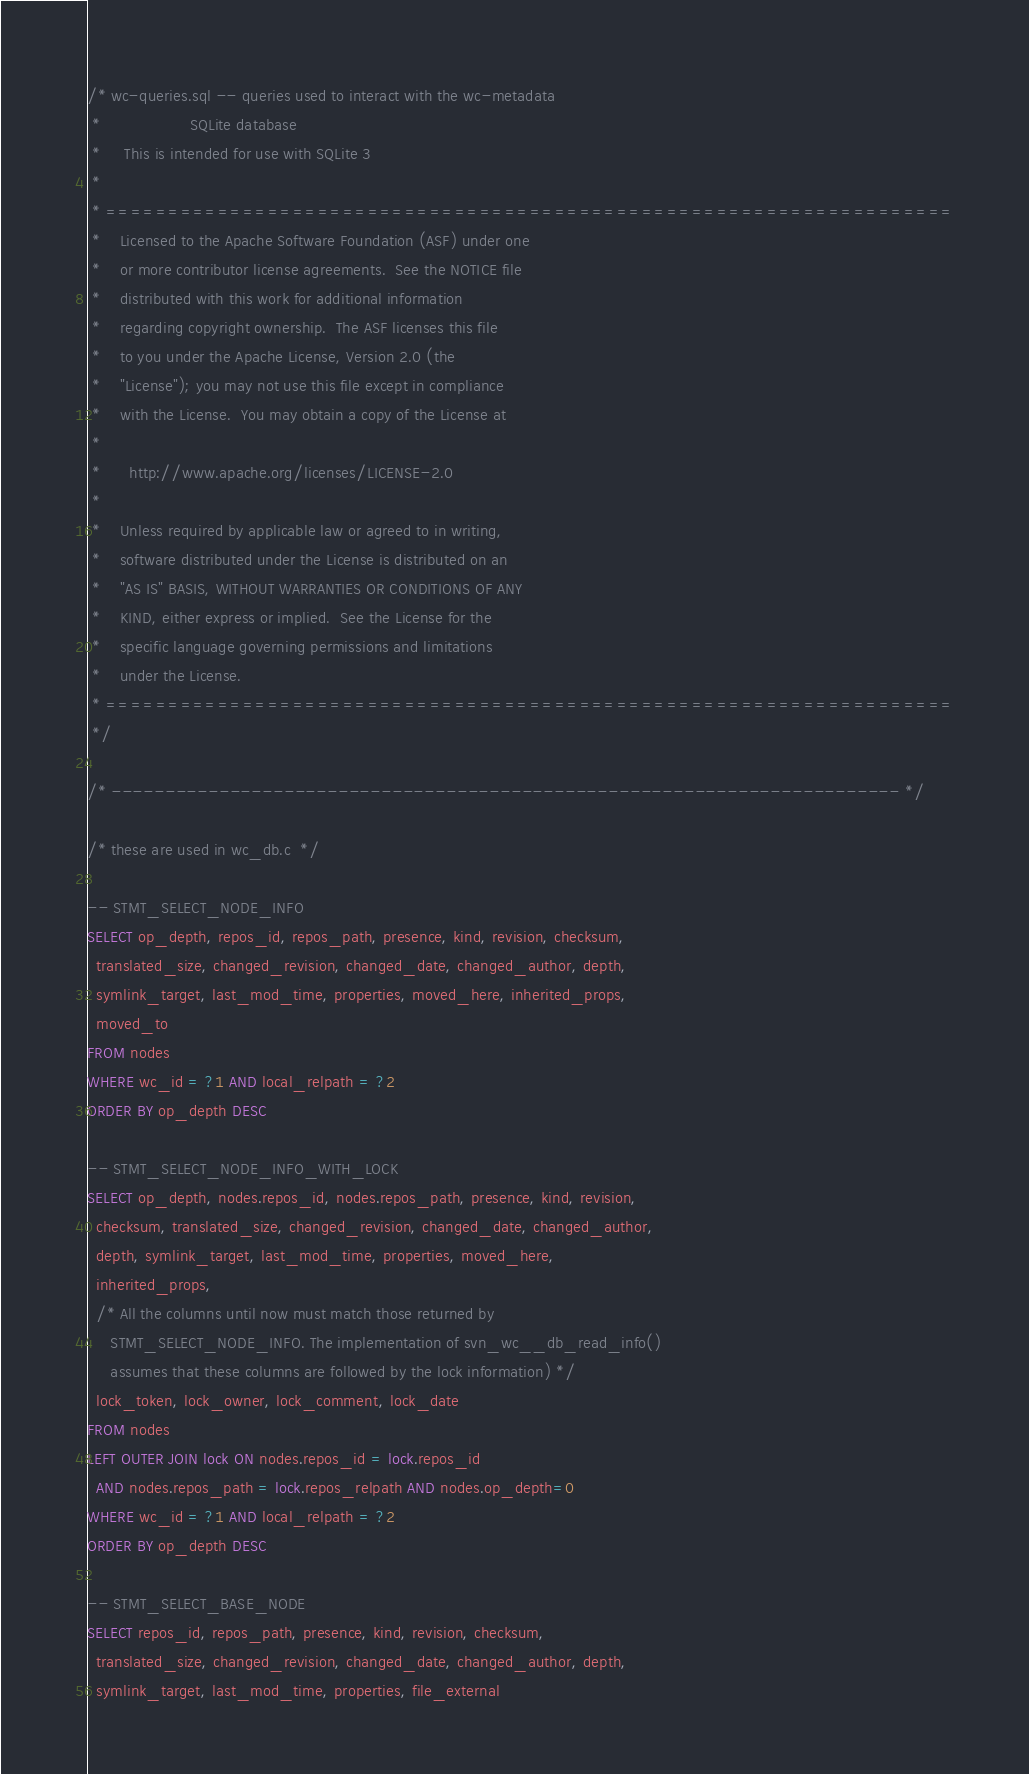<code> <loc_0><loc_0><loc_500><loc_500><_SQL_>/* wc-queries.sql -- queries used to interact with the wc-metadata
 *                   SQLite database
 *     This is intended for use with SQLite 3
 *
 * ====================================================================
 *    Licensed to the Apache Software Foundation (ASF) under one
 *    or more contributor license agreements.  See the NOTICE file
 *    distributed with this work for additional information
 *    regarding copyright ownership.  The ASF licenses this file
 *    to you under the Apache License, Version 2.0 (the
 *    "License"); you may not use this file except in compliance
 *    with the License.  You may obtain a copy of the License at
 *
 *      http://www.apache.org/licenses/LICENSE-2.0
 *
 *    Unless required by applicable law or agreed to in writing,
 *    software distributed under the License is distributed on an
 *    "AS IS" BASIS, WITHOUT WARRANTIES OR CONDITIONS OF ANY
 *    KIND, either express or implied.  See the License for the
 *    specific language governing permissions and limitations
 *    under the License.
 * ====================================================================
 */

/* ------------------------------------------------------------------------- */

/* these are used in wc_db.c  */

-- STMT_SELECT_NODE_INFO
SELECT op_depth, repos_id, repos_path, presence, kind, revision, checksum,
  translated_size, changed_revision, changed_date, changed_author, depth,
  symlink_target, last_mod_time, properties, moved_here, inherited_props,
  moved_to
FROM nodes
WHERE wc_id = ?1 AND local_relpath = ?2
ORDER BY op_depth DESC

-- STMT_SELECT_NODE_INFO_WITH_LOCK
SELECT op_depth, nodes.repos_id, nodes.repos_path, presence, kind, revision,
  checksum, translated_size, changed_revision, changed_date, changed_author,
  depth, symlink_target, last_mod_time, properties, moved_here,
  inherited_props,
  /* All the columns until now must match those returned by
     STMT_SELECT_NODE_INFO. The implementation of svn_wc__db_read_info()
     assumes that these columns are followed by the lock information) */
  lock_token, lock_owner, lock_comment, lock_date
FROM nodes
LEFT OUTER JOIN lock ON nodes.repos_id = lock.repos_id
  AND nodes.repos_path = lock.repos_relpath AND nodes.op_depth=0
WHERE wc_id = ?1 AND local_relpath = ?2
ORDER BY op_depth DESC

-- STMT_SELECT_BASE_NODE
SELECT repos_id, repos_path, presence, kind, revision, checksum,
  translated_size, changed_revision, changed_date, changed_author, depth,
  symlink_target, last_mod_time, properties, file_external</code> 